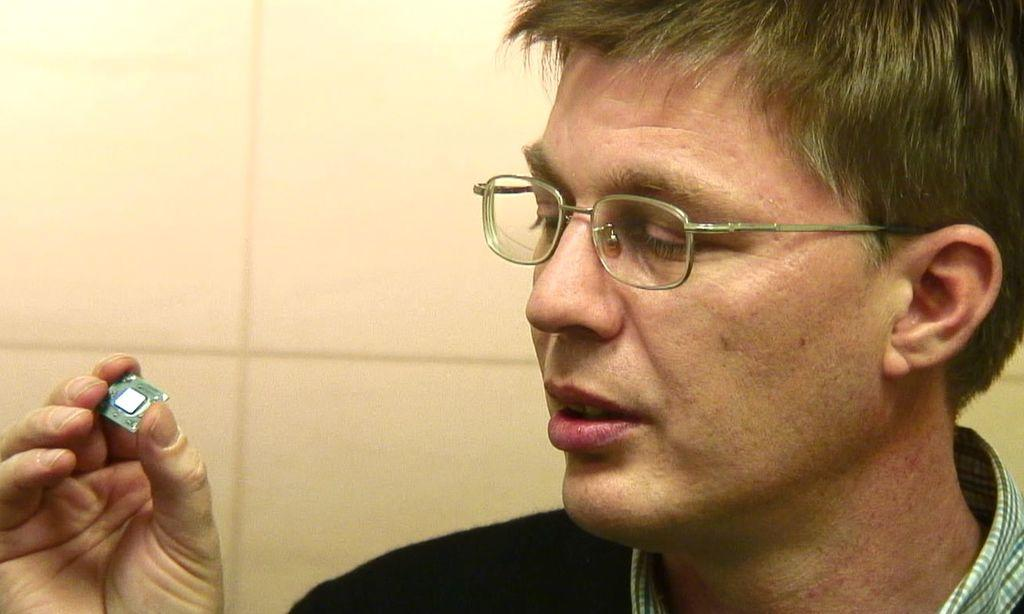What can be seen on the right side of the image? There is a person on the right side of the image. What is the person wearing? The person is wearing spectacles. What is the person holding in their hand? The person is holding an object in their hand. What is visible in the background of the image? There is a wall in the background of the image. Are there any giants visible in the image? No, there are no giants present in the image. What type of boot is the person wearing in the image? The person's footwear is not mentioned in the facts, so we cannot determine if they are wearing a boot or any other type of footwear. 